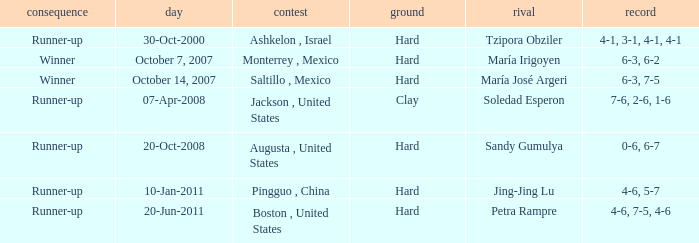Who was the opponent with a score of 4-6, 7-5, 4-6? Petra Rampre. Could you help me parse every detail presented in this table? {'header': ['consequence', 'day', 'contest', 'ground', 'rival', 'record'], 'rows': [['Runner-up', '30-Oct-2000', 'Ashkelon , Israel', 'Hard', 'Tzipora Obziler', '4-1, 3-1, 4-1, 4-1'], ['Winner', 'October 7, 2007', 'Monterrey , Mexico', 'Hard', 'María Irigoyen', '6-3, 6-2'], ['Winner', 'October 14, 2007', 'Saltillo , Mexico', 'Hard', 'María José Argeri', '6-3, 7-5'], ['Runner-up', '07-Apr-2008', 'Jackson , United States', 'Clay', 'Soledad Esperon', '7-6, 2-6, 1-6'], ['Runner-up', '20-Oct-2008', 'Augusta , United States', 'Hard', 'Sandy Gumulya', '0-6, 6-7'], ['Runner-up', '10-Jan-2011', 'Pingguo , China', 'Hard', 'Jing-Jing Lu', '4-6, 5-7'], ['Runner-up', '20-Jun-2011', 'Boston , United States', 'Hard', 'Petra Rampre', '4-6, 7-5, 4-6']]} 